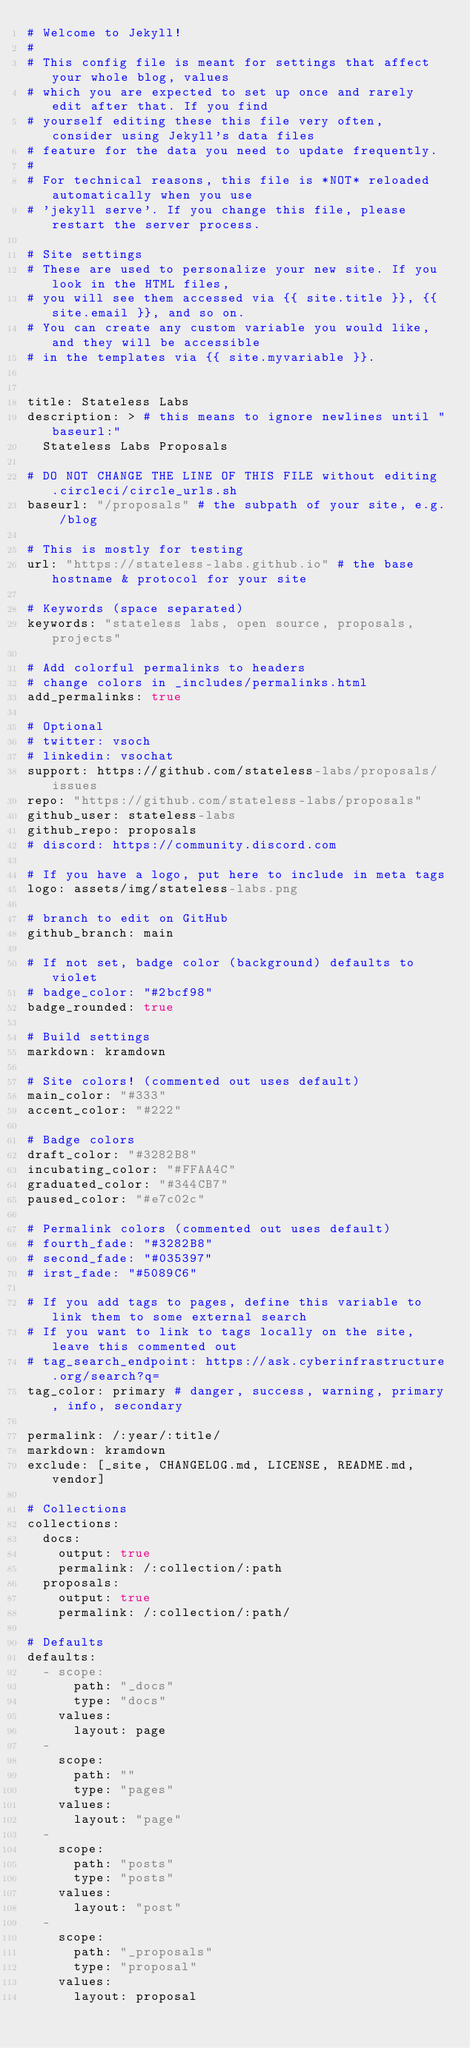<code> <loc_0><loc_0><loc_500><loc_500><_YAML_># Welcome to Jekyll!
#
# This config file is meant for settings that affect your whole blog, values
# which you are expected to set up once and rarely edit after that. If you find
# yourself editing these this file very often, consider using Jekyll's data files
# feature for the data you need to update frequently.
#
# For technical reasons, this file is *NOT* reloaded automatically when you use
# 'jekyll serve'. If you change this file, please restart the server process.

# Site settings
# These are used to personalize your new site. If you look in the HTML files,
# you will see them accessed via {{ site.title }}, {{ site.email }}, and so on.
# You can create any custom variable you would like, and they will be accessible
# in the templates via {{ site.myvariable }}.


title: Stateless Labs
description: > # this means to ignore newlines until "baseurl:"
  Stateless Labs Proposals

# DO NOT CHANGE THE LINE OF THIS FILE without editing .circleci/circle_urls.sh
baseurl: "/proposals" # the subpath of your site, e.g. /blog

# This is mostly for testing
url: "https://stateless-labs.github.io" # the base hostname & protocol for your site

# Keywords (space separated)
keywords: "stateless labs, open source, proposals, projects"

# Add colorful permalinks to headers
# change colors in _includes/permalinks.html
add_permalinks: true

# Optional
# twitter: vsoch
# linkedin: vsochat
support: https://github.com/stateless-labs/proposals/issues
repo: "https://github.com/stateless-labs/proposals"
github_user: stateless-labs
github_repo: proposals
# discord: https://community.discord.com

# If you have a logo, put here to include in meta tags
logo: assets/img/stateless-labs.png

# branch to edit on GitHub
github_branch: main

# If not set, badge color (background) defaults to violet
# badge_color: "#2bcf98"
badge_rounded: true

# Build settings
markdown: kramdown

# Site colors! (commented out uses default)
main_color: "#333"
accent_color: "#222"

# Badge colors
draft_color: "#3282B8"
incubating_color: "#FFAA4C"
graduated_color: "#344CB7"
paused_color: "#e7c02c"

# Permalink colors (commented out uses default)
# fourth_fade: "#3282B8"
# second_fade: "#035397"
# irst_fade: "#5089C6"

# If you add tags to pages, define this variable to link them to some external search
# If you want to link to tags locally on the site, leave this commented out
# tag_search_endpoint: https://ask.cyberinfrastructure.org/search?q=
tag_color: primary # danger, success, warning, primary, info, secondary

permalink: /:year/:title/
markdown: kramdown
exclude: [_site, CHANGELOG.md, LICENSE, README.md, vendor]

# Collections
collections:
  docs:
    output: true
    permalink: /:collection/:path
  proposals:
    output: true
    permalink: /:collection/:path/

# Defaults
defaults:
  - scope:
      path: "_docs"
      type: "docs"
    values:
      layout: page
  -
    scope:
      path: ""
      type: "pages"
    values:
      layout: "page"
  -
    scope:
      path: "posts"
      type: "posts"
    values:
      layout: "post"
  - 
    scope:
      path: "_proposals"
      type: "proposal"
    values:
      layout: proposal
</code> 